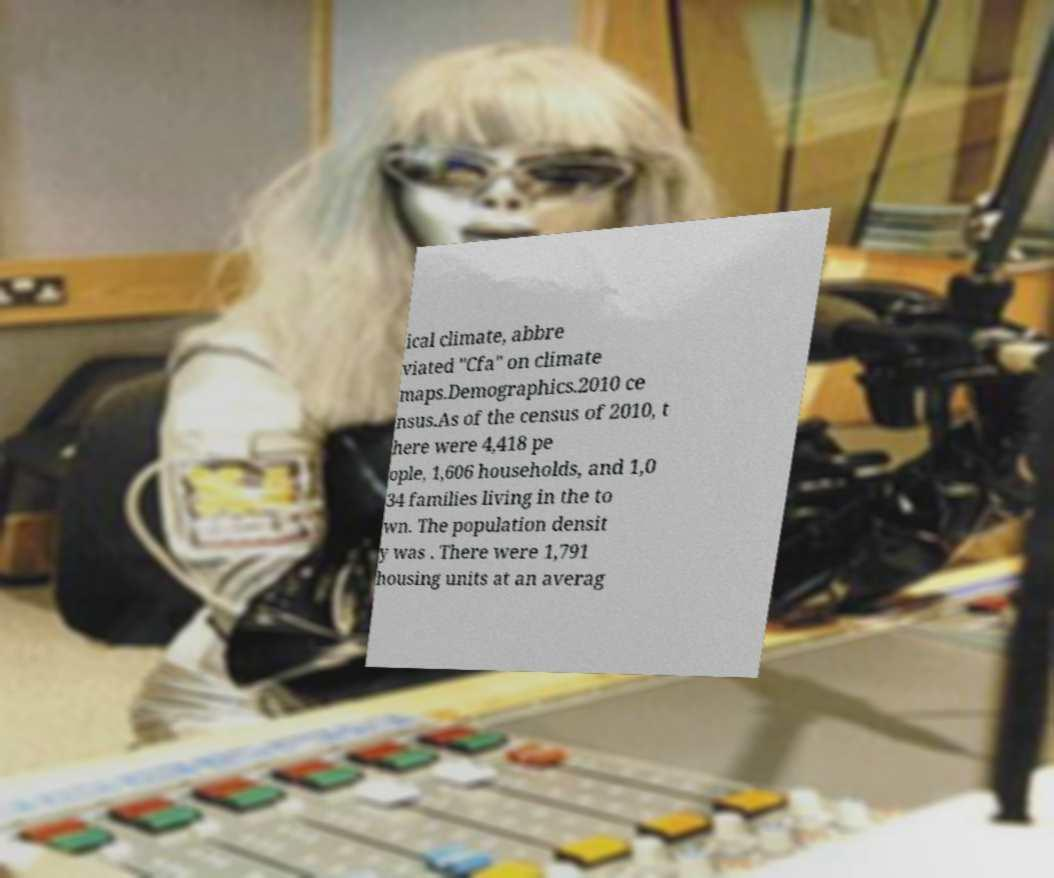Please identify and transcribe the text found in this image. ical climate, abbre viated "Cfa" on climate maps.Demographics.2010 ce nsus.As of the census of 2010, t here were 4,418 pe ople, 1,606 households, and 1,0 34 families living in the to wn. The population densit y was . There were 1,791 housing units at an averag 